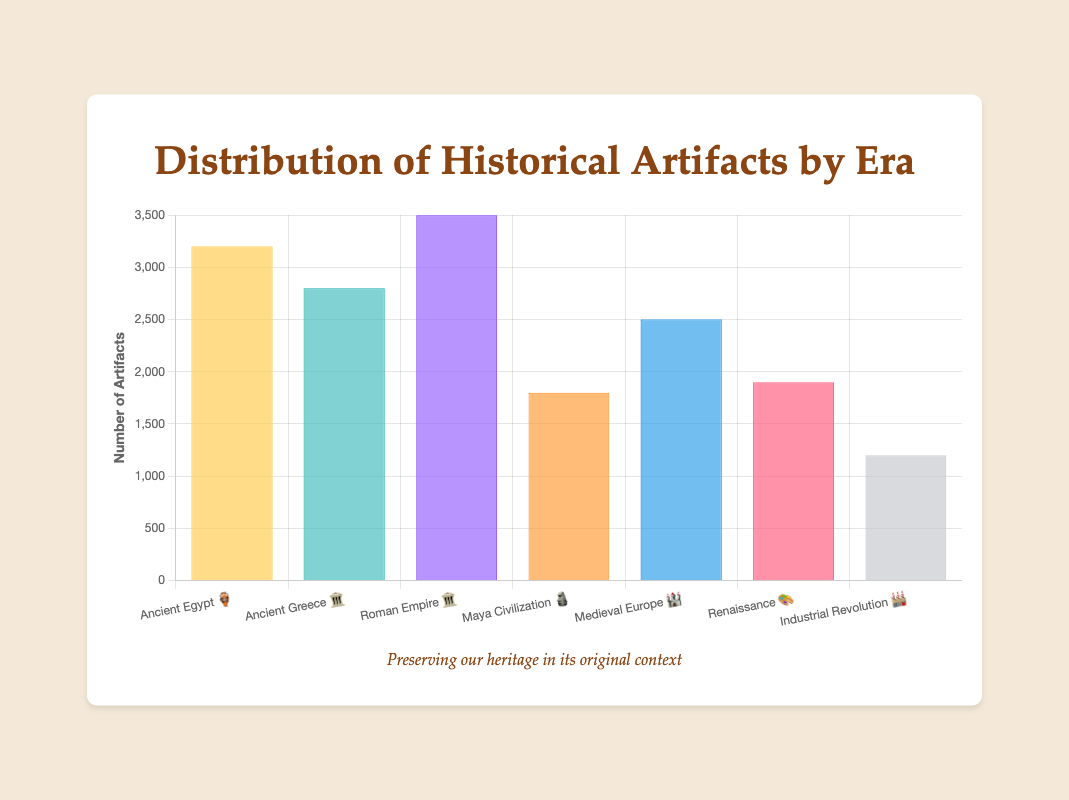Which era has the highest number of artifacts? Look at the bar chart and identify the tallest bar. The tallest bar belongs to the Roman Empire with 3500 artifacts.
Answer: Roman Empire Which two eras combined have the most artifacts? Add the number of artifacts from each era and find the highest sum. The sums are Ancient Egypt + Roman Empire (3200 + 3500 = 6700) and Roman Empire + Ancient Greece (3500 + 2800 = 6300), among others. The highest sum is from Ancient Egypt and Roman Empire.
Answer: Ancient Egypt and Roman Empire How many artifacts are there from Ancient Egypt 🏺? Locate Ancient Egypt on the x-axis and read the corresponding y-axis value. It shows 3200 artifacts.
Answer: 3200 What is the difference in the number of artifacts between the Maya Civilization 🗿 and the Renaissance 🎨? Subtract the number of Renaissance artifacts from Maya Civilization artifacts (1800 - 1900).
Answer: 100 Which era has fewer artifacts: the Renaissance 🎨 or the Industrial Revolution 🏭? Look at the heights of the bars for the Renaissance and the Industrial Revolution. The Industrial Revolution bar is shorter, representing 1200 artifacts compared to 1900 for the Renaissance.
Answer: Industrial Revolution How does the number of artifacts from Medieval Europe 🏰 compare to those from Ancient Greece 🏛️? Compare the bars for Medieval Europe and Ancient Greece. Medieval Europe has 2500 artifacts, and Ancient Greece has 2800. So, Ancient Greece has more.
Answer: Ancient Greece has more What is the average number of artifacts across all eras represented? Sum the number of artifacts from all eras (3200 + 2800 + 3500 + 1800 + 2500 + 1900 + 1200 = 16900) and then divide by the number of eras (16900 / 7).
Answer: 2414.29 Which era between Ancient Greece 🏛️ and the Roman Empire 🏛️ has more artifacts? Compare the bars for Ancient Greece and Roman Empire. The Roman Empire has more artifacts (3500 compared to 2800 in Ancient Greece).
Answer: Roman Empire 